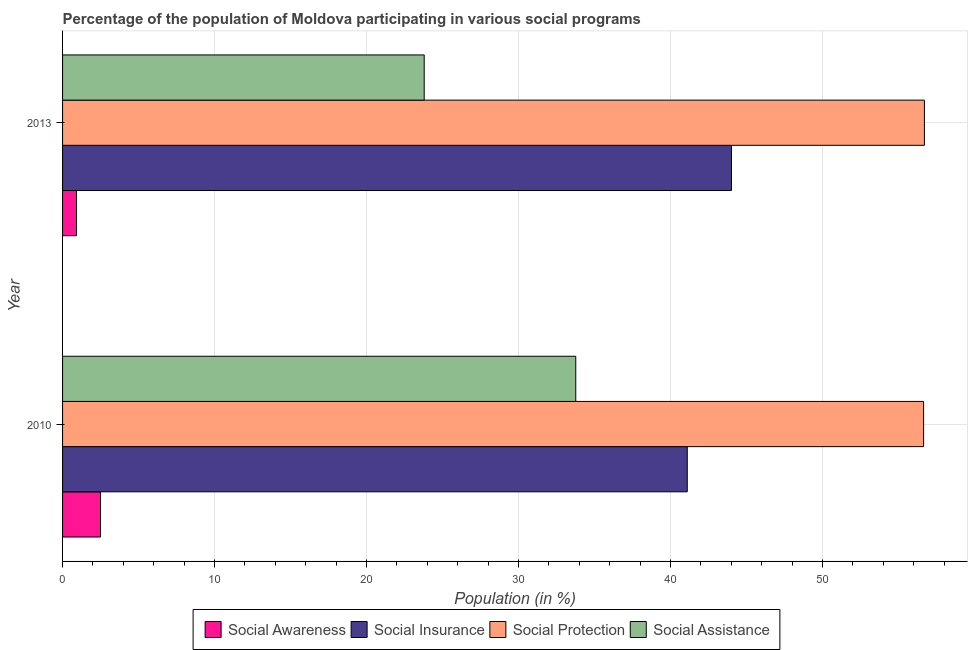Are the number of bars on each tick of the Y-axis equal?
Make the answer very short. Yes. How many bars are there on the 1st tick from the top?
Keep it short and to the point. 4. How many bars are there on the 2nd tick from the bottom?
Provide a short and direct response. 4. What is the participation of population in social protection programs in 2010?
Provide a short and direct response. 56.65. Across all years, what is the maximum participation of population in social protection programs?
Keep it short and to the point. 56.7. Across all years, what is the minimum participation of population in social assistance programs?
Provide a short and direct response. 23.79. In which year was the participation of population in social insurance programs maximum?
Your answer should be compact. 2013. What is the total participation of population in social awareness programs in the graph?
Keep it short and to the point. 3.41. What is the difference between the participation of population in social protection programs in 2010 and that in 2013?
Your answer should be very brief. -0.05. What is the difference between the participation of population in social protection programs in 2010 and the participation of population in social assistance programs in 2013?
Make the answer very short. 32.85. What is the average participation of population in social protection programs per year?
Keep it short and to the point. 56.67. In the year 2013, what is the difference between the participation of population in social protection programs and participation of population in social assistance programs?
Your response must be concise. 32.91. In how many years, is the participation of population in social awareness programs greater than 16 %?
Ensure brevity in your answer.  0. What is the ratio of the participation of population in social assistance programs in 2010 to that in 2013?
Your response must be concise. 1.42. Is it the case that in every year, the sum of the participation of population in social protection programs and participation of population in social awareness programs is greater than the sum of participation of population in social insurance programs and participation of population in social assistance programs?
Your answer should be very brief. No. What does the 3rd bar from the top in 2010 represents?
Your answer should be very brief. Social Insurance. What does the 2nd bar from the bottom in 2013 represents?
Offer a terse response. Social Insurance. Is it the case that in every year, the sum of the participation of population in social awareness programs and participation of population in social insurance programs is greater than the participation of population in social protection programs?
Make the answer very short. No. How many years are there in the graph?
Your answer should be compact. 2. Does the graph contain any zero values?
Offer a very short reply. No. Does the graph contain grids?
Give a very brief answer. Yes. What is the title of the graph?
Offer a terse response. Percentage of the population of Moldova participating in various social programs . What is the label or title of the X-axis?
Keep it short and to the point. Population (in %). What is the label or title of the Y-axis?
Keep it short and to the point. Year. What is the Population (in %) of Social Awareness in 2010?
Your answer should be compact. 2.5. What is the Population (in %) in Social Insurance in 2010?
Provide a short and direct response. 41.1. What is the Population (in %) in Social Protection in 2010?
Make the answer very short. 56.65. What is the Population (in %) of Social Assistance in 2010?
Offer a terse response. 33.76. What is the Population (in %) of Social Awareness in 2013?
Provide a succinct answer. 0.92. What is the Population (in %) of Social Insurance in 2013?
Give a very brief answer. 44.01. What is the Population (in %) in Social Protection in 2013?
Ensure brevity in your answer.  56.7. What is the Population (in %) in Social Assistance in 2013?
Provide a short and direct response. 23.79. Across all years, what is the maximum Population (in %) of Social Awareness?
Give a very brief answer. 2.5. Across all years, what is the maximum Population (in %) of Social Insurance?
Your response must be concise. 44.01. Across all years, what is the maximum Population (in %) in Social Protection?
Make the answer very short. 56.7. Across all years, what is the maximum Population (in %) of Social Assistance?
Ensure brevity in your answer.  33.76. Across all years, what is the minimum Population (in %) in Social Awareness?
Your response must be concise. 0.92. Across all years, what is the minimum Population (in %) of Social Insurance?
Offer a terse response. 41.1. Across all years, what is the minimum Population (in %) in Social Protection?
Make the answer very short. 56.65. Across all years, what is the minimum Population (in %) of Social Assistance?
Your answer should be very brief. 23.79. What is the total Population (in %) in Social Awareness in the graph?
Your answer should be compact. 3.41. What is the total Population (in %) in Social Insurance in the graph?
Give a very brief answer. 85.1. What is the total Population (in %) of Social Protection in the graph?
Your answer should be compact. 113.35. What is the total Population (in %) in Social Assistance in the graph?
Give a very brief answer. 57.56. What is the difference between the Population (in %) of Social Awareness in 2010 and that in 2013?
Give a very brief answer. 1.58. What is the difference between the Population (in %) in Social Insurance in 2010 and that in 2013?
Provide a short and direct response. -2.91. What is the difference between the Population (in %) of Social Protection in 2010 and that in 2013?
Provide a short and direct response. -0.05. What is the difference between the Population (in %) of Social Assistance in 2010 and that in 2013?
Provide a succinct answer. 9.97. What is the difference between the Population (in %) in Social Awareness in 2010 and the Population (in %) in Social Insurance in 2013?
Offer a very short reply. -41.51. What is the difference between the Population (in %) of Social Awareness in 2010 and the Population (in %) of Social Protection in 2013?
Provide a short and direct response. -54.2. What is the difference between the Population (in %) of Social Awareness in 2010 and the Population (in %) of Social Assistance in 2013?
Your answer should be compact. -21.3. What is the difference between the Population (in %) of Social Insurance in 2010 and the Population (in %) of Social Protection in 2013?
Provide a short and direct response. -15.6. What is the difference between the Population (in %) of Social Insurance in 2010 and the Population (in %) of Social Assistance in 2013?
Your response must be concise. 17.31. What is the difference between the Population (in %) in Social Protection in 2010 and the Population (in %) in Social Assistance in 2013?
Give a very brief answer. 32.85. What is the average Population (in %) of Social Awareness per year?
Keep it short and to the point. 1.71. What is the average Population (in %) in Social Insurance per year?
Your answer should be compact. 42.55. What is the average Population (in %) of Social Protection per year?
Provide a succinct answer. 56.67. What is the average Population (in %) of Social Assistance per year?
Make the answer very short. 28.78. In the year 2010, what is the difference between the Population (in %) in Social Awareness and Population (in %) in Social Insurance?
Make the answer very short. -38.6. In the year 2010, what is the difference between the Population (in %) of Social Awareness and Population (in %) of Social Protection?
Your answer should be compact. -54.15. In the year 2010, what is the difference between the Population (in %) in Social Awareness and Population (in %) in Social Assistance?
Make the answer very short. -31.27. In the year 2010, what is the difference between the Population (in %) of Social Insurance and Population (in %) of Social Protection?
Your response must be concise. -15.55. In the year 2010, what is the difference between the Population (in %) in Social Insurance and Population (in %) in Social Assistance?
Offer a terse response. 7.33. In the year 2010, what is the difference between the Population (in %) in Social Protection and Population (in %) in Social Assistance?
Offer a terse response. 22.88. In the year 2013, what is the difference between the Population (in %) of Social Awareness and Population (in %) of Social Insurance?
Your answer should be very brief. -43.09. In the year 2013, what is the difference between the Population (in %) in Social Awareness and Population (in %) in Social Protection?
Keep it short and to the point. -55.78. In the year 2013, what is the difference between the Population (in %) in Social Awareness and Population (in %) in Social Assistance?
Your answer should be very brief. -22.88. In the year 2013, what is the difference between the Population (in %) in Social Insurance and Population (in %) in Social Protection?
Offer a terse response. -12.69. In the year 2013, what is the difference between the Population (in %) of Social Insurance and Population (in %) of Social Assistance?
Keep it short and to the point. 20.21. In the year 2013, what is the difference between the Population (in %) in Social Protection and Population (in %) in Social Assistance?
Your answer should be compact. 32.91. What is the ratio of the Population (in %) of Social Awareness in 2010 to that in 2013?
Your answer should be very brief. 2.73. What is the ratio of the Population (in %) in Social Insurance in 2010 to that in 2013?
Your response must be concise. 0.93. What is the ratio of the Population (in %) of Social Assistance in 2010 to that in 2013?
Give a very brief answer. 1.42. What is the difference between the highest and the second highest Population (in %) in Social Awareness?
Your answer should be compact. 1.58. What is the difference between the highest and the second highest Population (in %) in Social Insurance?
Your answer should be very brief. 2.91. What is the difference between the highest and the second highest Population (in %) of Social Protection?
Ensure brevity in your answer.  0.05. What is the difference between the highest and the second highest Population (in %) in Social Assistance?
Provide a short and direct response. 9.97. What is the difference between the highest and the lowest Population (in %) in Social Awareness?
Offer a very short reply. 1.58. What is the difference between the highest and the lowest Population (in %) in Social Insurance?
Your response must be concise. 2.91. What is the difference between the highest and the lowest Population (in %) in Social Protection?
Your response must be concise. 0.05. What is the difference between the highest and the lowest Population (in %) of Social Assistance?
Your answer should be very brief. 9.97. 